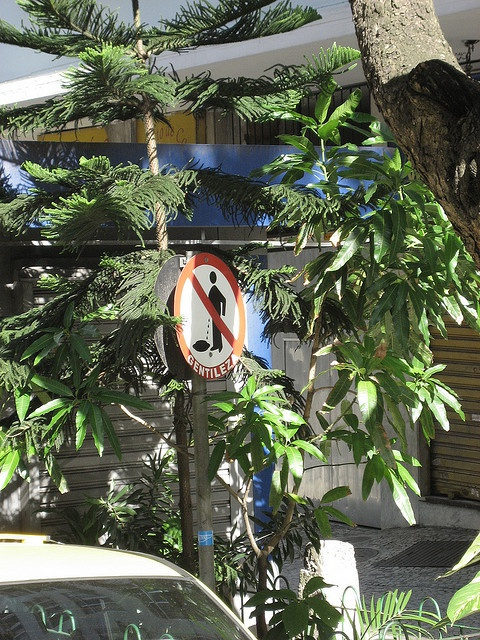Describe the objects in this image and their specific colors. I can see a car in darkgray, gray, ivory, black, and darkgreen tones in this image. 